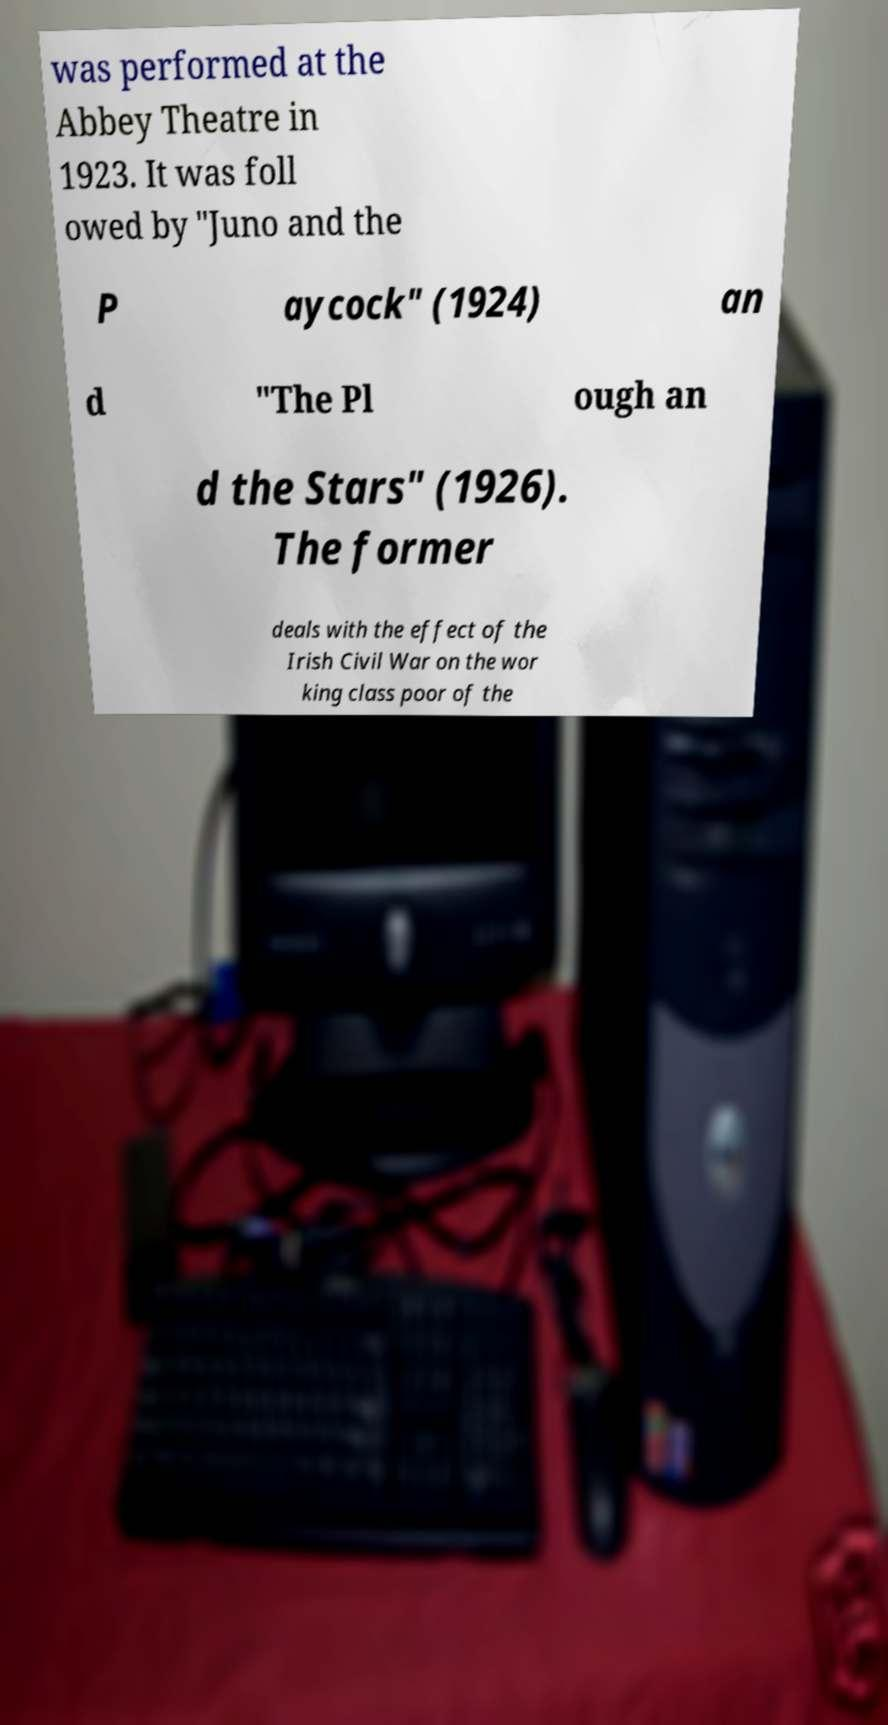What messages or text are displayed in this image? I need them in a readable, typed format. was performed at the Abbey Theatre in 1923. It was foll owed by "Juno and the P aycock" (1924) an d "The Pl ough an d the Stars" (1926). The former deals with the effect of the Irish Civil War on the wor king class poor of the 